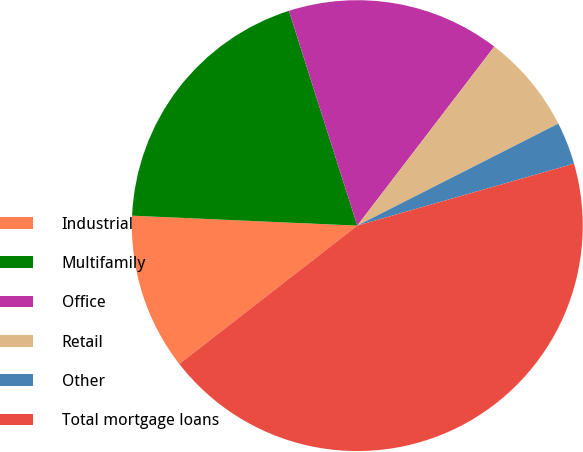Convert chart. <chart><loc_0><loc_0><loc_500><loc_500><pie_chart><fcel>Industrial<fcel>Multifamily<fcel>Office<fcel>Retail<fcel>Other<fcel>Total mortgage loans<nl><fcel>11.22%<fcel>19.39%<fcel>15.3%<fcel>7.13%<fcel>3.04%<fcel>43.91%<nl></chart> 